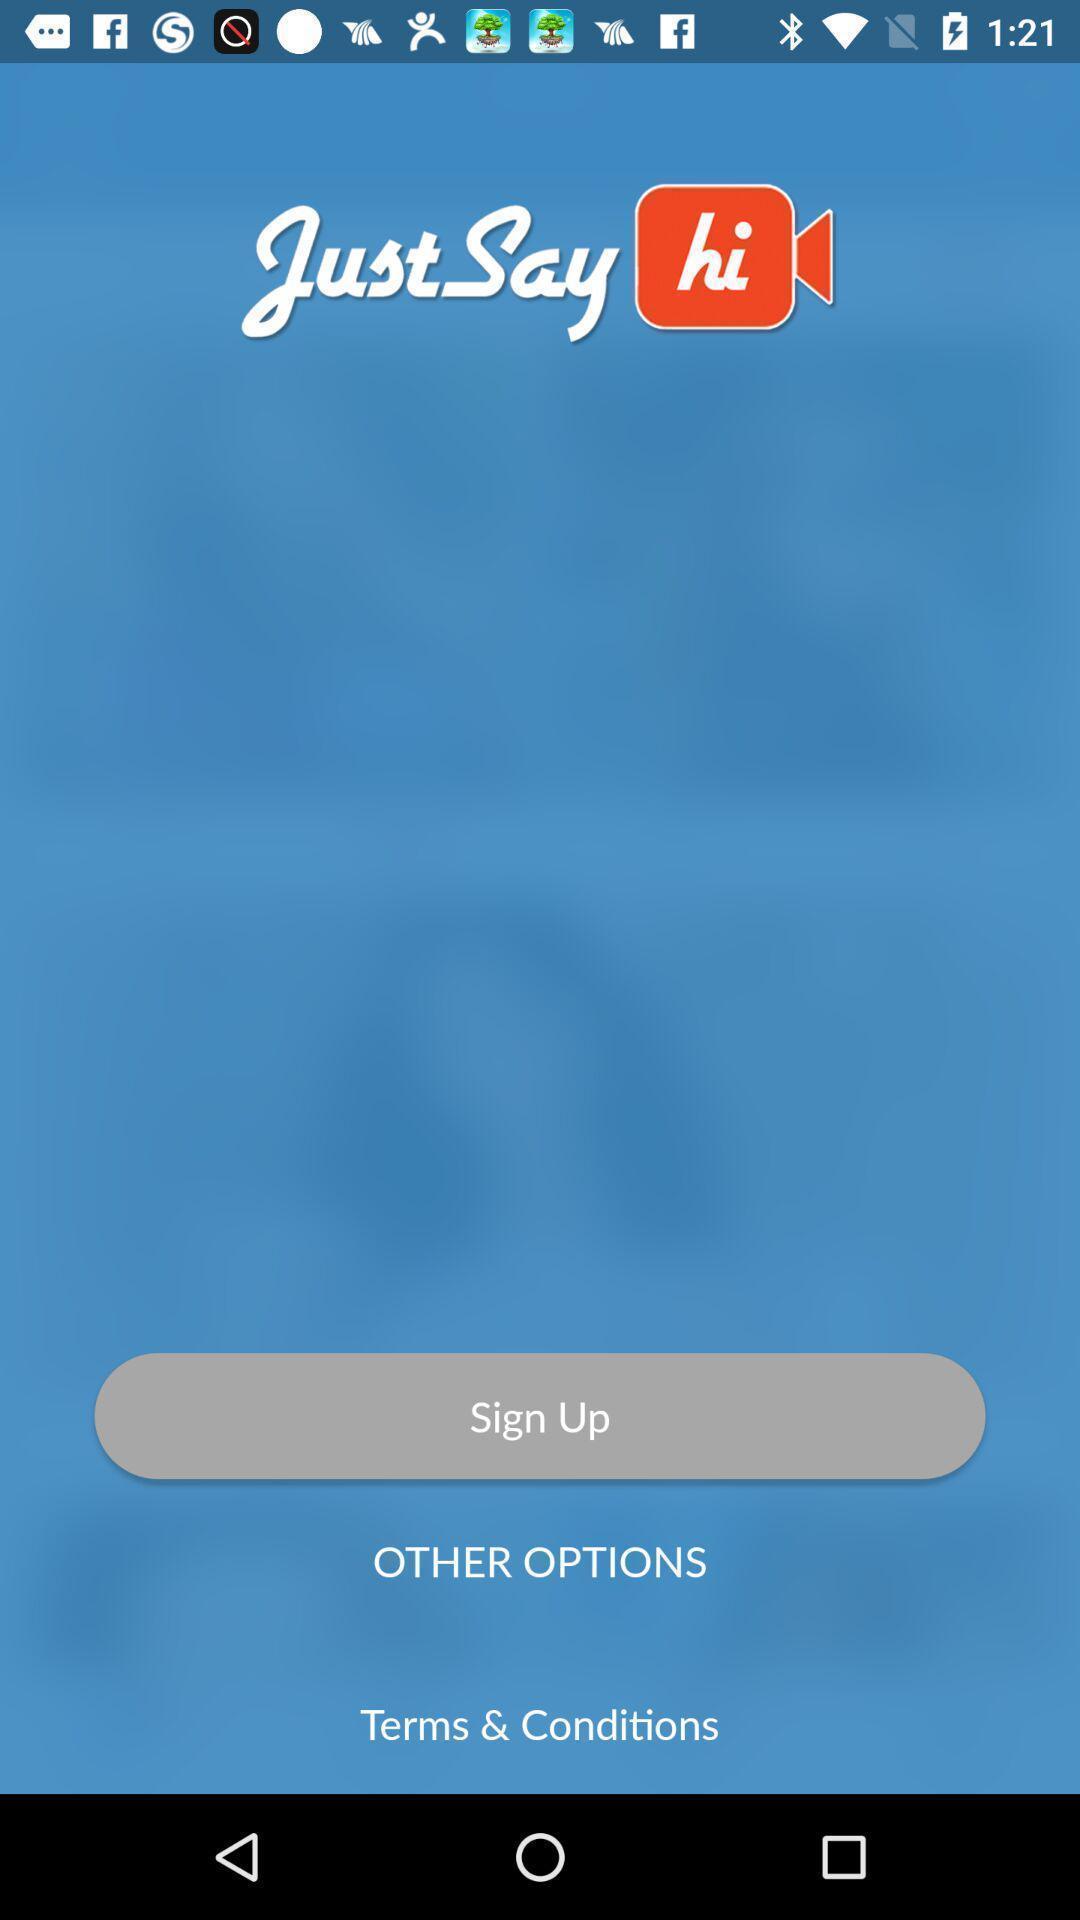Give me a summary of this screen capture. Sign up page. 